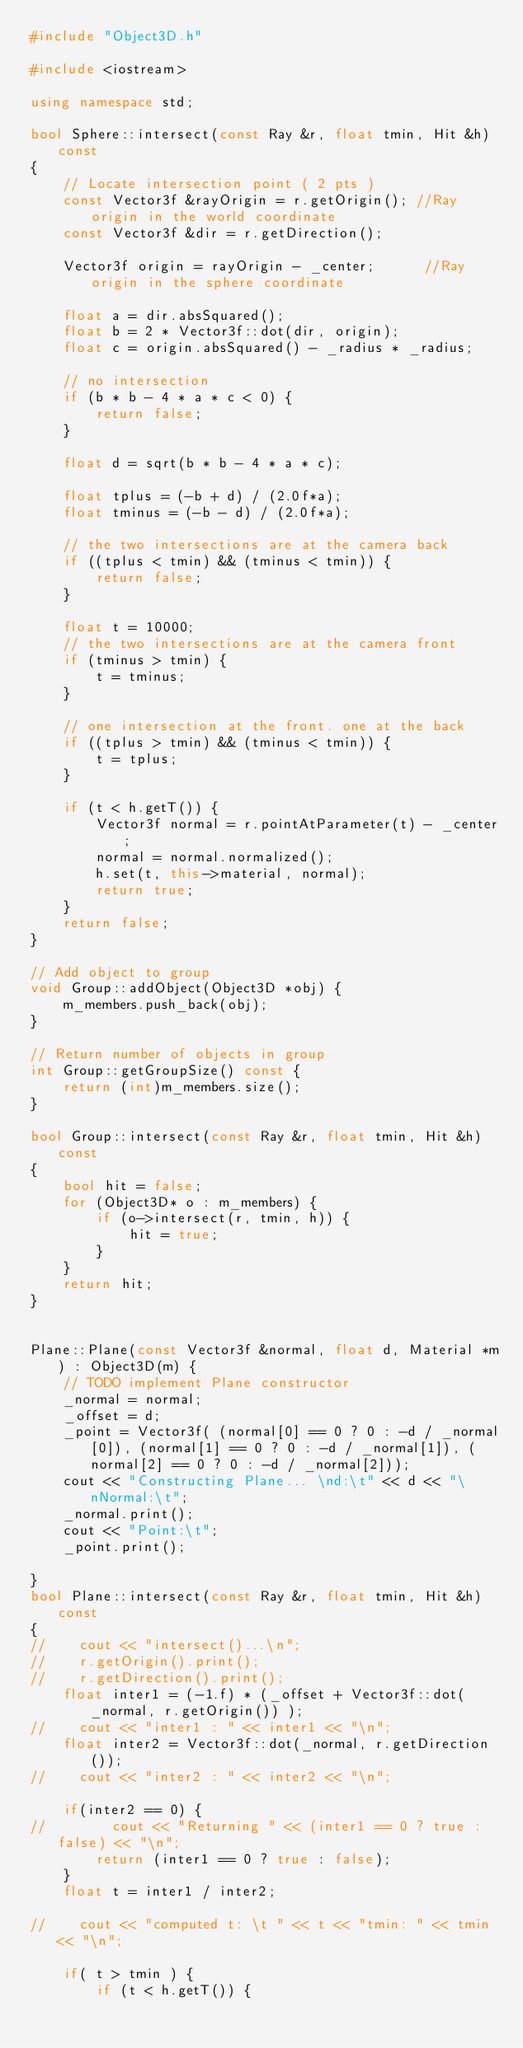<code> <loc_0><loc_0><loc_500><loc_500><_C++_>#include "Object3D.h"

#include <iostream>

using namespace std;

bool Sphere::intersect(const Ray &r, float tmin, Hit &h) const
{
    // Locate intersection point ( 2 pts )
    const Vector3f &rayOrigin = r.getOrigin(); //Ray origin in the world coordinate
    const Vector3f &dir = r.getDirection();

    Vector3f origin = rayOrigin - _center;      //Ray origin in the sphere coordinate

    float a = dir.absSquared();
    float b = 2 * Vector3f::dot(dir, origin);
    float c = origin.absSquared() - _radius * _radius;

    // no intersection
    if (b * b - 4 * a * c < 0) {
        return false;
    }

    float d = sqrt(b * b - 4 * a * c);

    float tplus = (-b + d) / (2.0f*a);
    float tminus = (-b - d) / (2.0f*a);

    // the two intersections are at the camera back
    if ((tplus < tmin) && (tminus < tmin)) {
        return false;
    }

    float t = 10000;
    // the two intersections are at the camera front
    if (tminus > tmin) {
        t = tminus;
    }

    // one intersection at the front. one at the back 
    if ((tplus > tmin) && (tminus < tmin)) {
        t = tplus;
    }

    if (t < h.getT()) {
        Vector3f normal = r.pointAtParameter(t) - _center;
        normal = normal.normalized();
        h.set(t, this->material, normal);
        return true;
    }
    return false;
}

// Add object to group
void Group::addObject(Object3D *obj) {
    m_members.push_back(obj);
}

// Return number of objects in group
int Group::getGroupSize() const {
    return (int)m_members.size();
}

bool Group::intersect(const Ray &r, float tmin, Hit &h) const
{
    bool hit = false;
    for (Object3D* o : m_members) {
        if (o->intersect(r, tmin, h)) {
            hit = true;
        }
    }
    return hit;
}


Plane::Plane(const Vector3f &normal, float d, Material *m) : Object3D(m) {
    // TODO implement Plane constructor
    _normal = normal;
    _offset = d;
    _point = Vector3f( (normal[0] == 0 ? 0 : -d / _normal[0]), (normal[1] == 0 ? 0 : -d / _normal[1]), (normal[2] == 0 ? 0 : -d / _normal[2]));
    cout << "Constructing Plane... \nd:\t" << d << "\nNormal:\t";
    _normal.print();
    cout << "Point:\t";
    _point.print();
    
}
bool Plane::intersect(const Ray &r, float tmin, Hit &h) const
{
//    cout << "intersect()...\n";
//    r.getOrigin().print();
//    r.getDirection().print();
    float inter1 = (-1.f) * (_offset + Vector3f::dot(_normal, r.getOrigin()) );
//    cout << "inter1 : " << inter1 << "\n";
    float inter2 = Vector3f::dot(_normal, r.getDirection());
//    cout << "inter2 : " << inter2 << "\n";
    
    if(inter2 == 0) {
//        cout << "Returning " << (inter1 == 0 ? true : false) << "\n";
        return (inter1 == 0 ? true : false);
    }
    float t = inter1 / inter2;
    
//    cout << "computed t: \t " << t << "tmin: " << tmin << "\n";
    
    if( t > tmin ) {
        if (t < h.getT()) {</code> 